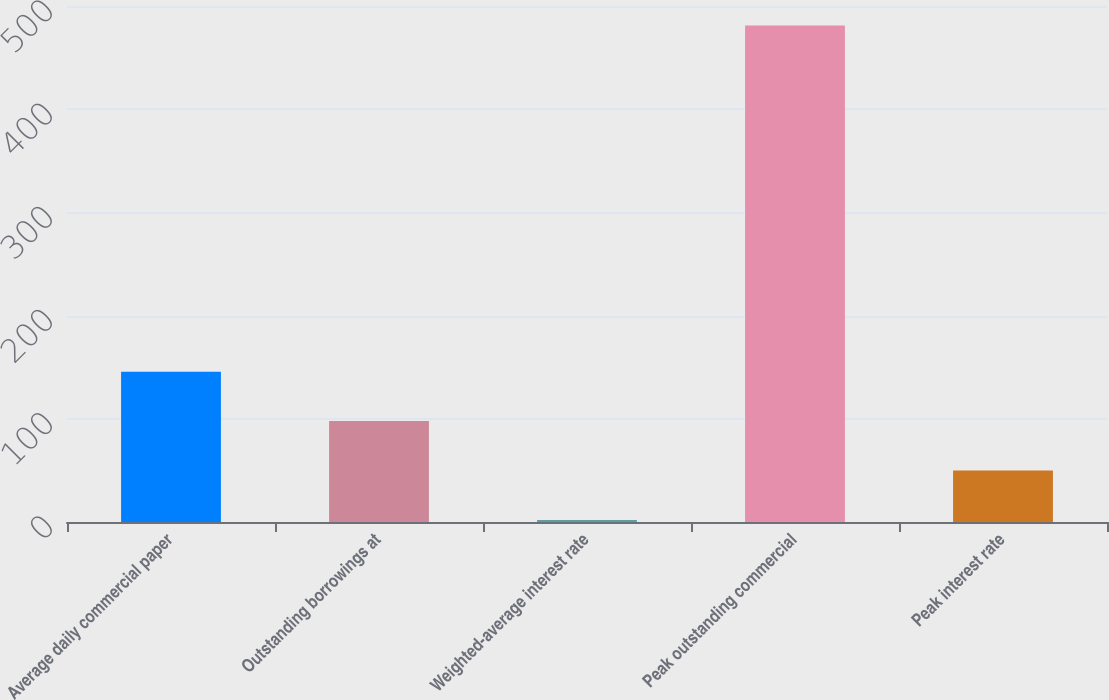Convert chart to OTSL. <chart><loc_0><loc_0><loc_500><loc_500><bar_chart><fcel>Average daily commercial paper<fcel>Outstanding borrowings at<fcel>Weighted-average interest rate<fcel>Peak outstanding commercial<fcel>Peak interest rate<nl><fcel>145.67<fcel>97.76<fcel>1.94<fcel>481<fcel>49.85<nl></chart> 